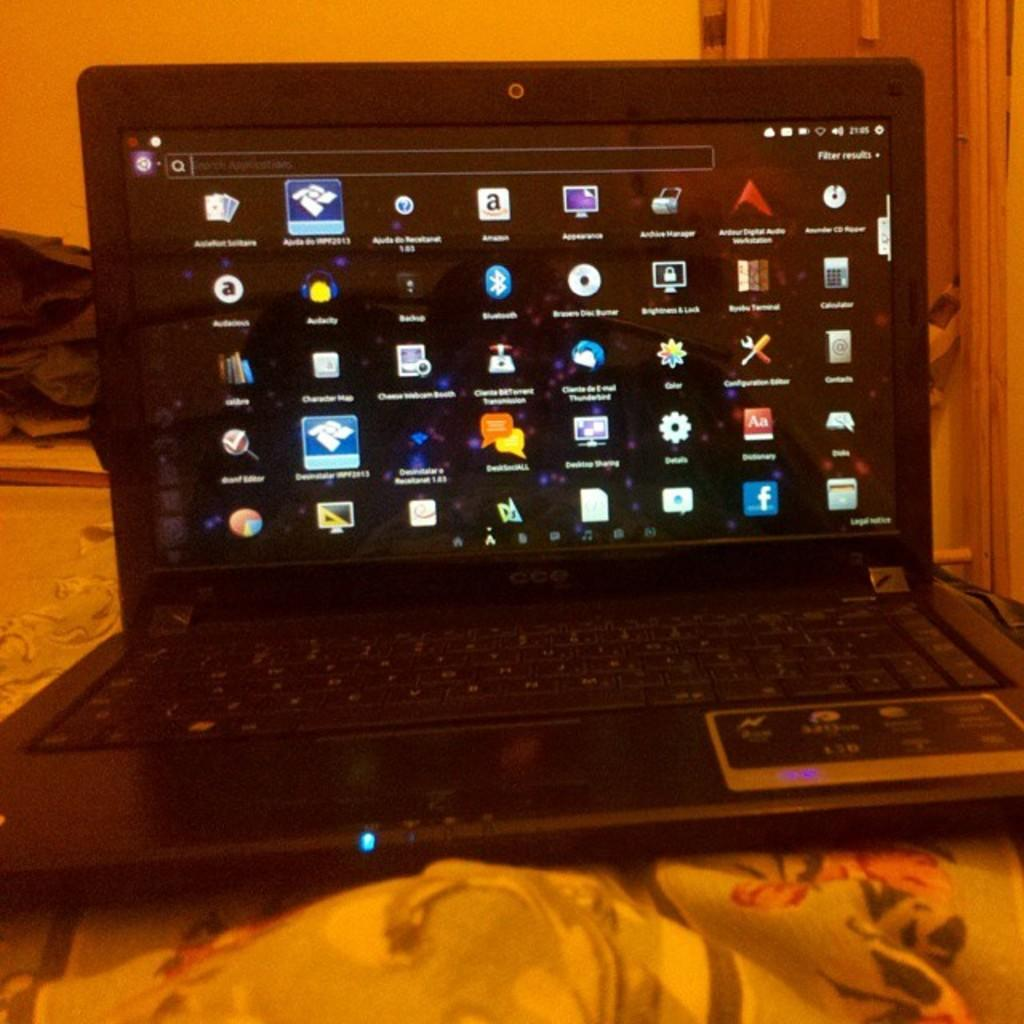What electronic device is visible in the image? There is a laptop in the image. Where is the laptop placed? The laptop is on a blanket. What can be seen in the background of the image? There is a wall and a polythene cover in the background of the image. How many girls are playing with the corn in the image? There are no girls or corn present in the image. 